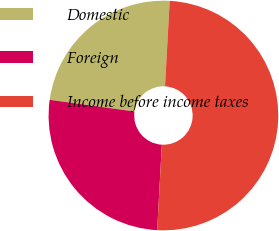<chart> <loc_0><loc_0><loc_500><loc_500><pie_chart><fcel>Domestic<fcel>Foreign<fcel>Income before income taxes<nl><fcel>23.69%<fcel>26.32%<fcel>50.0%<nl></chart> 